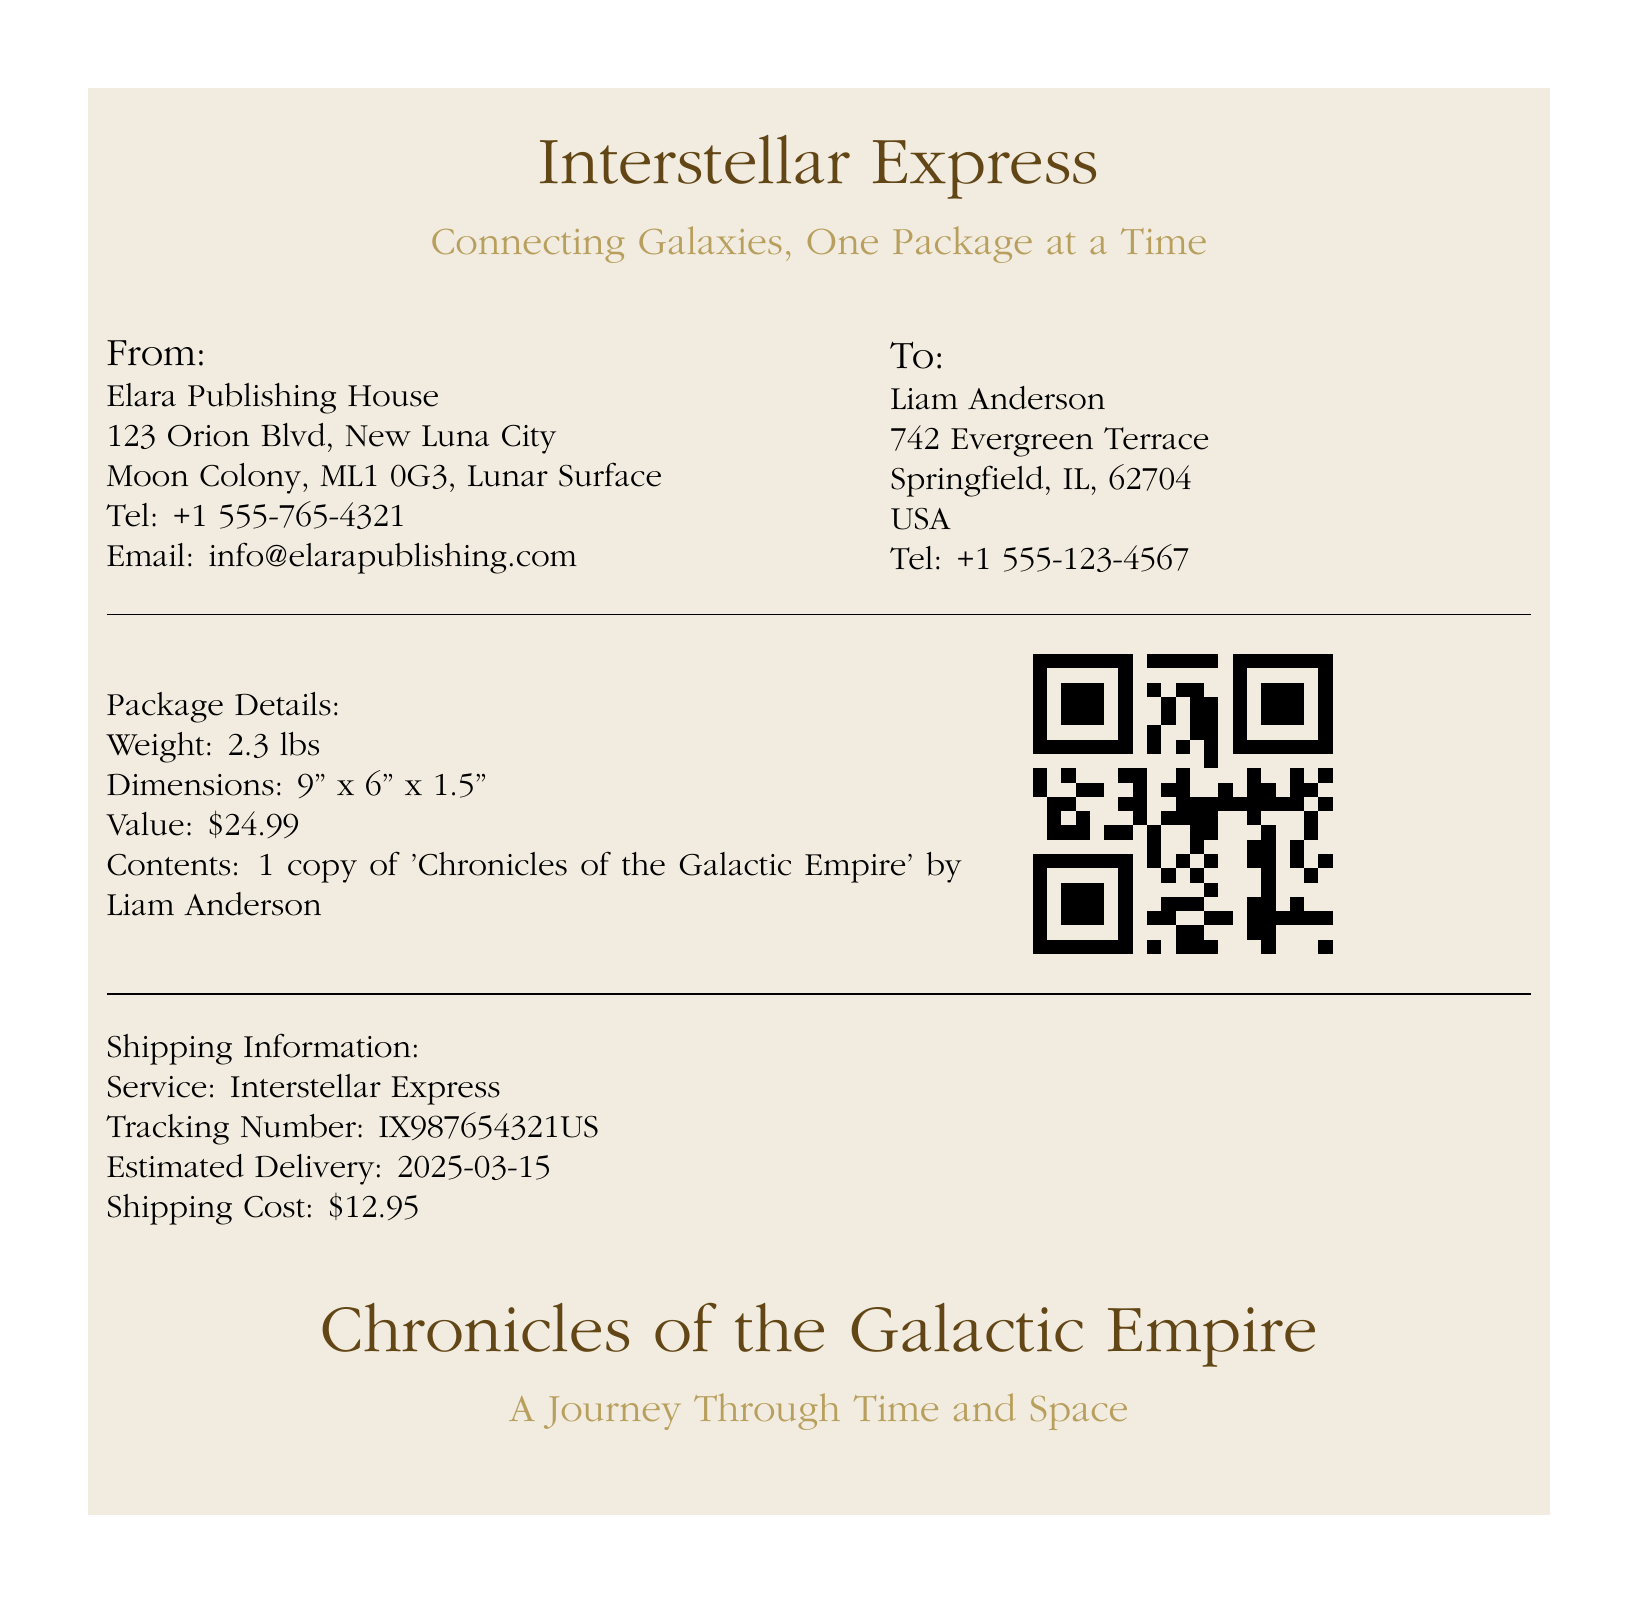What is the weight of the package? The weight is listed in the Package Details section of the document, which is 2.3 lbs.
Answer: 2.3 lbs What is the estimated delivery date? The estimated delivery date can be found in the Shipping Information section, which states 2025-03-15.
Answer: 2025-03-15 Who is the sender of the package? The sender's information is found in the From section, which lists Elara Publishing House.
Answer: Elara Publishing House What is the tracking number? The tracking number is mentioned in the Shipping Information section as IX987654321US.
Answer: IX987654321US What is the content of the package? The content is indicated in the Package Details section, which states it contains 1 copy of 'Chronicles of the Galactic Empire' by Liam Anderson.
Answer: 1 copy of 'Chronicles of the Galactic Empire' How much is the shipping cost? The shipping cost is specified in the Shipping Information section, which is $12.95.
Answer: $12.95 What is the value of the package? The value can be found in the Package Details section, which is $24.99.
Answer: $24.99 Which service is being used for shipping? The shipping service is detailed in the Shipping Information section, which is Interstellar Express.
Answer: Interstellar Express What are the dimensions of the package? The dimensions are listed in the Package Details section as 9" x 6" x 1.5".
Answer: 9" x 6" x 1.5" 